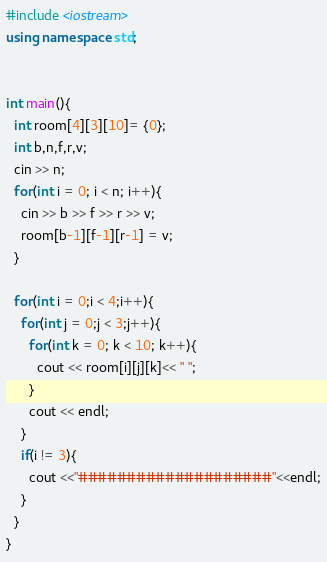Convert code to text. <code><loc_0><loc_0><loc_500><loc_500><_C++_>#include <iostream>
using namespace std;


int main(){
  int room[4][3][10]= {0};
  int b,n,f,r,v;
  cin >> n;
  for(int i = 0; i < n; i++){
    cin >> b >> f >> r >> v;
    room[b-1][f-1][r-1] = v;
  }

  for(int i = 0;i < 4;i++){
    for(int j = 0;j < 3;j++){
      for(int k = 0; k < 10; k++){
        cout << room[i][j][k]<< " ";
      }   
      cout << endl;
    }   
    if(i != 3){ 
      cout <<"####################"<<endl;
    }   
  }
}</code> 